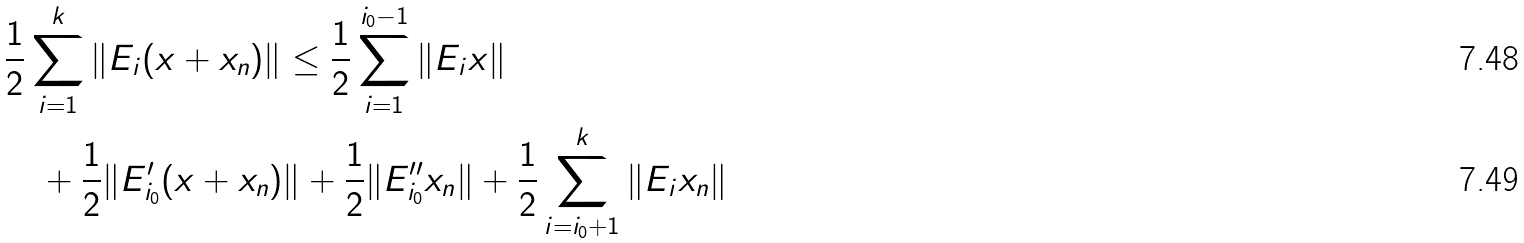<formula> <loc_0><loc_0><loc_500><loc_500>& \frac { 1 } { 2 } \sum _ { i = 1 } ^ { k } \| E _ { i } ( x + x _ { n } ) \| \leq \frac { 1 } { 2 } \sum _ { i = 1 } ^ { i _ { 0 } - 1 } \| E _ { i } x \| \\ & \quad + \frac { 1 } { 2 } \| E ^ { \prime } _ { i _ { 0 } } ( x + x _ { n } ) \| + \frac { 1 } { 2 } \| E ^ { \prime \prime } _ { i _ { 0 } } x _ { n } \| + \frac { 1 } { 2 } \sum _ { i = i _ { 0 } + 1 } ^ { k } \| E _ { i } x _ { n } \|</formula> 